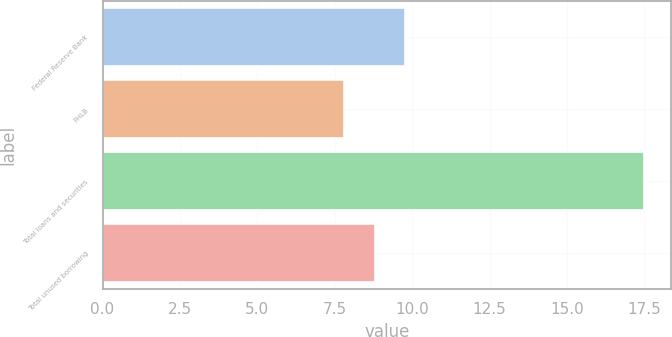Convert chart to OTSL. <chart><loc_0><loc_0><loc_500><loc_500><bar_chart><fcel>Federal Reserve Bank<fcel>FHLB<fcel>Total loans and securities<fcel>Total unused borrowing<nl><fcel>9.77<fcel>7.8<fcel>17.5<fcel>8.8<nl></chart> 